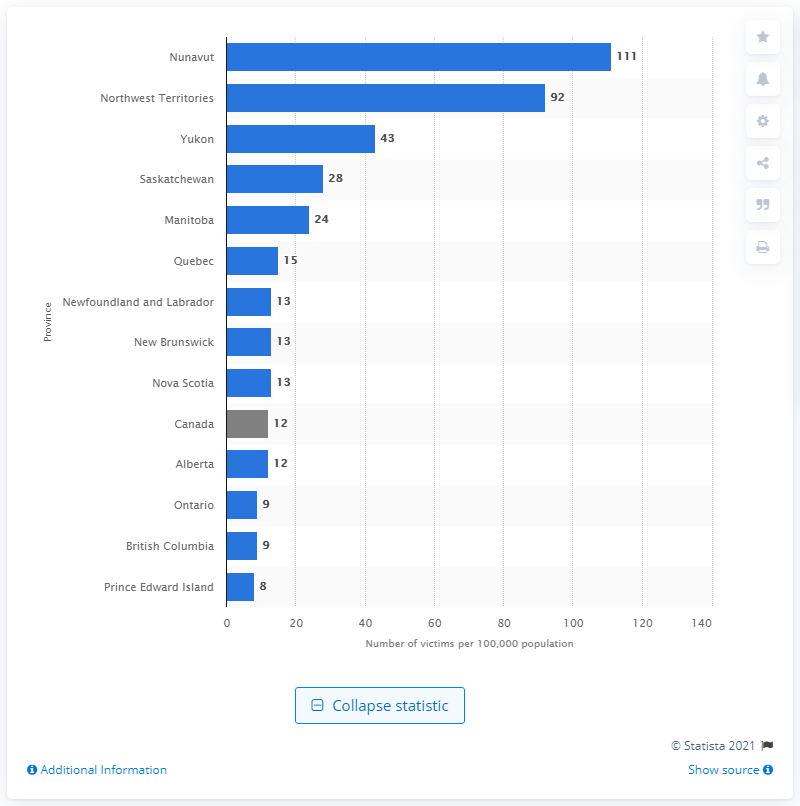Specify some key components in this picture. In Nunavut, family members have reportedly committed the highest rate of sexual assault. In 2016, an estimated 111 sexual assault victims per 100,000 people lived in Nunavut. 